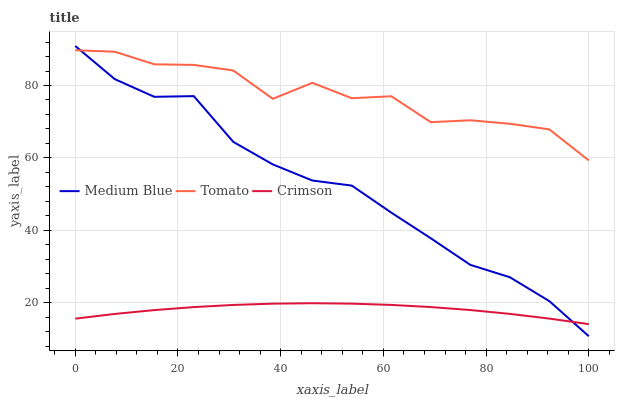Does Crimson have the minimum area under the curve?
Answer yes or no. Yes. Does Tomato have the maximum area under the curve?
Answer yes or no. Yes. Does Medium Blue have the minimum area under the curve?
Answer yes or no. No. Does Medium Blue have the maximum area under the curve?
Answer yes or no. No. Is Crimson the smoothest?
Answer yes or no. Yes. Is Tomato the roughest?
Answer yes or no. Yes. Is Medium Blue the smoothest?
Answer yes or no. No. Is Medium Blue the roughest?
Answer yes or no. No. Does Medium Blue have the lowest value?
Answer yes or no. Yes. Does Crimson have the lowest value?
Answer yes or no. No. Does Medium Blue have the highest value?
Answer yes or no. Yes. Does Crimson have the highest value?
Answer yes or no. No. Is Crimson less than Tomato?
Answer yes or no. Yes. Is Tomato greater than Crimson?
Answer yes or no. Yes. Does Medium Blue intersect Crimson?
Answer yes or no. Yes. Is Medium Blue less than Crimson?
Answer yes or no. No. Is Medium Blue greater than Crimson?
Answer yes or no. No. Does Crimson intersect Tomato?
Answer yes or no. No. 